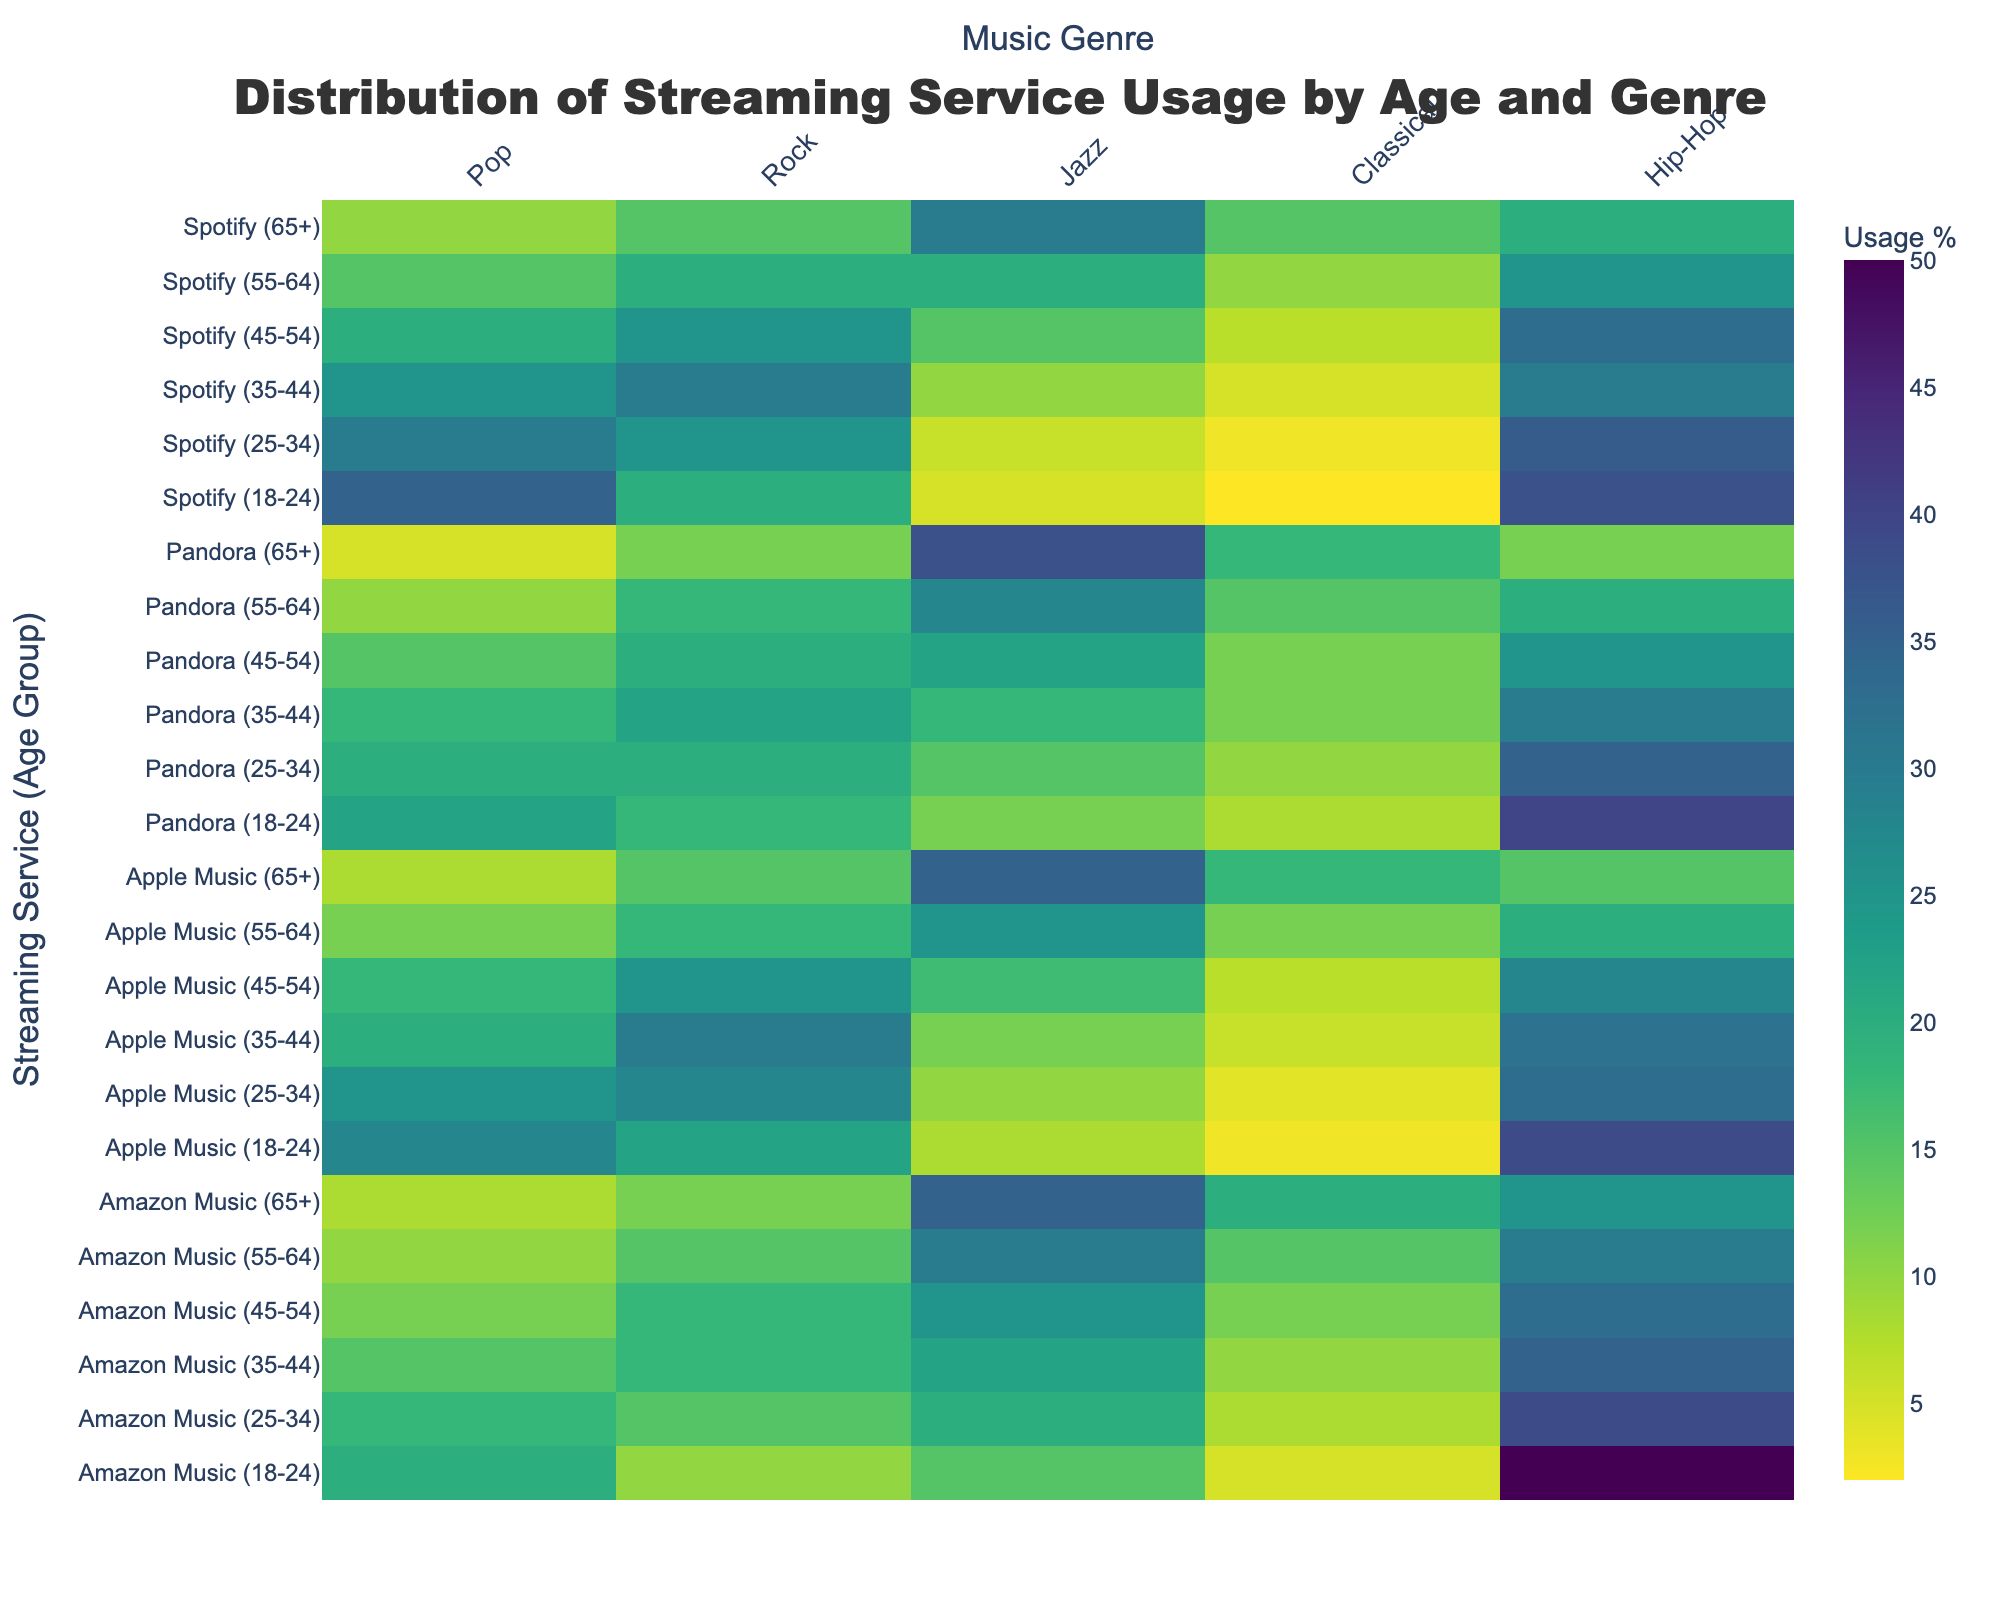What is the title of the heatmap? The title of the heatmap is usually displayed prominently at the top of the figure; it gives an overview of what the data represents. In this case, the title is "Distribution of Streaming Service Usage by Age and Genre" as stated in the code.
Answer: Distribution of Streaming Service Usage by Age and Genre Which streaming service and age group combination shows the highest usage for Hip-Hop? To find this, look at the heatmap and identify the cell with the highest value in the Hip-Hop column, and then see which streaming service and age group that row belongs to.
Answer: Amazon Music (18-24) How does the usage of Classical music by the 55-64 age group compare between Spotify and Apple Music? Check the heatmap for the Classical music usage values for Spotify (55-64) and Apple Music (55-64). Compare these two numbers to determine which is higher.
Answer: Apple Music has higher usage What is the color scale used in the heatmap? The color scale in the heatmap indicates the intensity of usage percentages. The colors change based on usage values and typically range from light to dark shades. In this case, the code specifies the 'Viridis' colorscale, which progresses from purple and blue to green and yellow.
Answer: Viridis Which music genre has the least usage percentage across all streaming services? To answer, observe the heatmap to identify the genre with the consistently lowest values across all entries.
Answer: Classical For Apple Music, which age group shows the highest usage for Jazz? Look at the row entries for Apple Music and compare the values in the Jazz column to determine the age group with the highest number.
Answer: 65+ What is the average usage percentage for Rock music across all streaming services for the 35-44 age group? Identify and sum the Rock usage percentages for the 35-44 age group across all streaming services and divide by the number of services (4). For Spotify: 30, for Apple Music: 30, for Amazon Music: 18, for Pandora: 22. (30+30+18+22)/4 = 100/4 = 25.
Answer: 25 Which age group has the most distinct pattern of music genre preferences across different streaming services? Look for the age group with the highest variance in usage percentages across different genres and streaming services, indicating a distinct pattern. This can be recognized by differing colors/shades across that age group's row entries.
Answer: 65+ Do younger age groups prefer Pop or Hip-Hop on Pandora? By examining the usage percentages for Pop and Hip-Hop for the younger age groups (18-24 and 25-34) on Pandora in the heatmap, determine which genre has higher values.
Answer: Hip-Hop Compare the popularity of Jazz among the 18-24 age group between Amazon Music and Spotify. Find the Jazz usage percentage for the 18-24 age group on both Amazon Music and Spotify from the heatmap and compare them.
Answer: Amazon Music is higher 